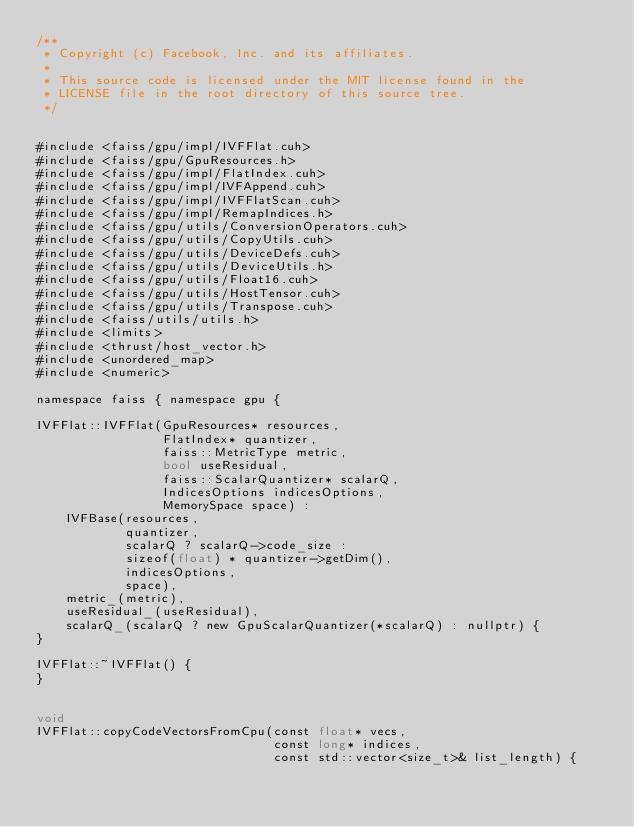Convert code to text. <code><loc_0><loc_0><loc_500><loc_500><_Cuda_>/**
 * Copyright (c) Facebook, Inc. and its affiliates.
 *
 * This source code is licensed under the MIT license found in the
 * LICENSE file in the root directory of this source tree.
 */


#include <faiss/gpu/impl/IVFFlat.cuh>
#include <faiss/gpu/GpuResources.h>
#include <faiss/gpu/impl/FlatIndex.cuh>
#include <faiss/gpu/impl/IVFAppend.cuh>
#include <faiss/gpu/impl/IVFFlatScan.cuh>
#include <faiss/gpu/impl/RemapIndices.h>
#include <faiss/gpu/utils/ConversionOperators.cuh>
#include <faiss/gpu/utils/CopyUtils.cuh>
#include <faiss/gpu/utils/DeviceDefs.cuh>
#include <faiss/gpu/utils/DeviceUtils.h>
#include <faiss/gpu/utils/Float16.cuh>
#include <faiss/gpu/utils/HostTensor.cuh>
#include <faiss/gpu/utils/Transpose.cuh>
#include <faiss/utils/utils.h>
#include <limits>
#include <thrust/host_vector.h>
#include <unordered_map>
#include <numeric>

namespace faiss { namespace gpu {

IVFFlat::IVFFlat(GpuResources* resources,
                 FlatIndex* quantizer,
                 faiss::MetricType metric,
                 bool useResidual,
                 faiss::ScalarQuantizer* scalarQ,
                 IndicesOptions indicesOptions,
                 MemorySpace space) :
    IVFBase(resources,
            quantizer,
            scalarQ ? scalarQ->code_size :
            sizeof(float) * quantizer->getDim(),
            indicesOptions,
            space),
    metric_(metric),
    useResidual_(useResidual),
    scalarQ_(scalarQ ? new GpuScalarQuantizer(*scalarQ) : nullptr) {
}

IVFFlat::~IVFFlat() {
}


void
IVFFlat::copyCodeVectorsFromCpu(const float* vecs,
                                const long* indices,
                                const std::vector<size_t>& list_length) {</code> 